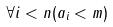Convert formula to latex. <formula><loc_0><loc_0><loc_500><loc_500>\forall i < n ( a _ { i } < m )</formula> 